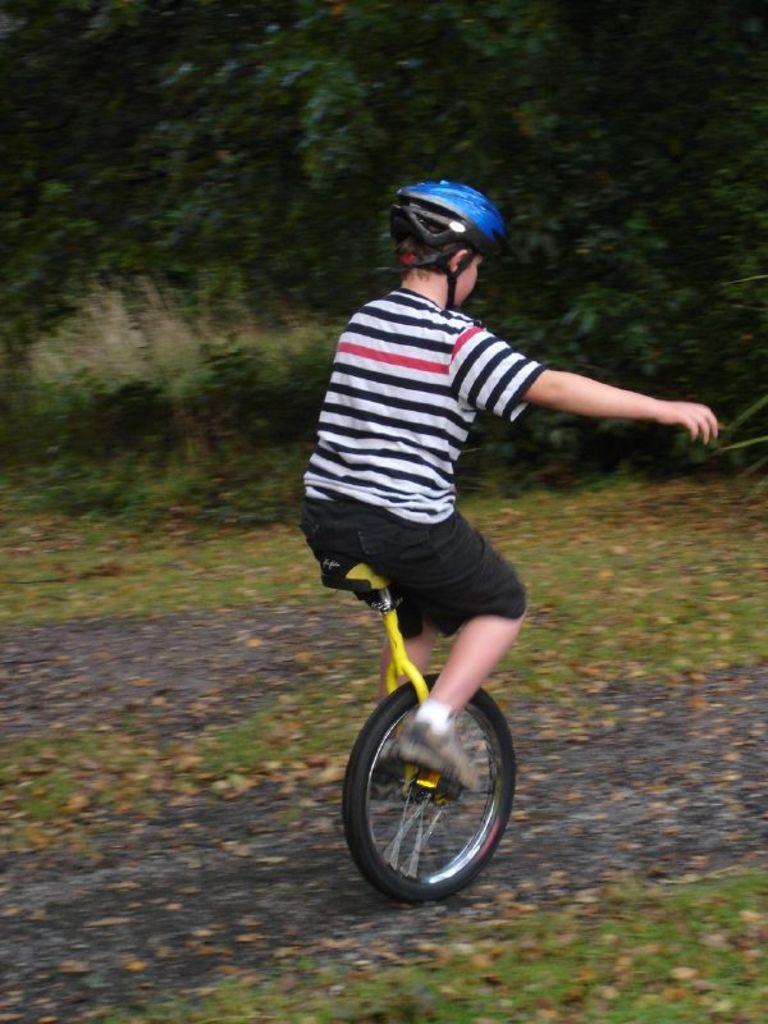How would you summarize this image in a sentence or two? In the image a person is riding unicycle. Behind the person there are some trees and grass. 